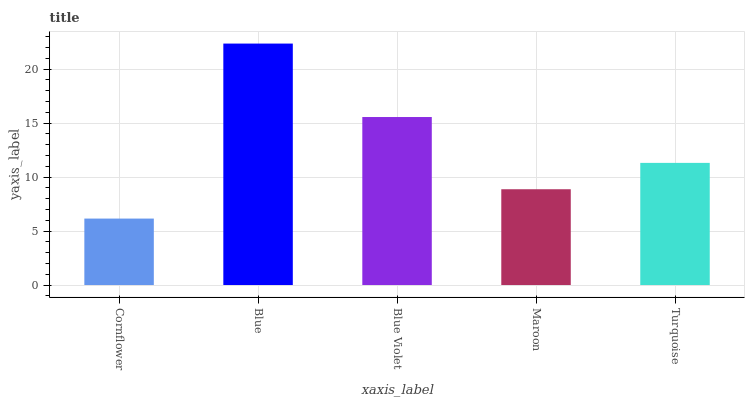Is Cornflower the minimum?
Answer yes or no. Yes. Is Blue the maximum?
Answer yes or no. Yes. Is Blue Violet the minimum?
Answer yes or no. No. Is Blue Violet the maximum?
Answer yes or no. No. Is Blue greater than Blue Violet?
Answer yes or no. Yes. Is Blue Violet less than Blue?
Answer yes or no. Yes. Is Blue Violet greater than Blue?
Answer yes or no. No. Is Blue less than Blue Violet?
Answer yes or no. No. Is Turquoise the high median?
Answer yes or no. Yes. Is Turquoise the low median?
Answer yes or no. Yes. Is Blue Violet the high median?
Answer yes or no. No. Is Cornflower the low median?
Answer yes or no. No. 